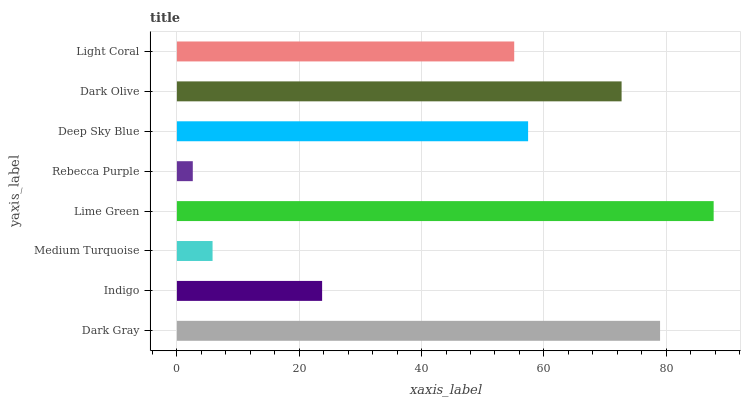Is Rebecca Purple the minimum?
Answer yes or no. Yes. Is Lime Green the maximum?
Answer yes or no. Yes. Is Indigo the minimum?
Answer yes or no. No. Is Indigo the maximum?
Answer yes or no. No. Is Dark Gray greater than Indigo?
Answer yes or no. Yes. Is Indigo less than Dark Gray?
Answer yes or no. Yes. Is Indigo greater than Dark Gray?
Answer yes or no. No. Is Dark Gray less than Indigo?
Answer yes or no. No. Is Deep Sky Blue the high median?
Answer yes or no. Yes. Is Light Coral the low median?
Answer yes or no. Yes. Is Dark Gray the high median?
Answer yes or no. No. Is Rebecca Purple the low median?
Answer yes or no. No. 